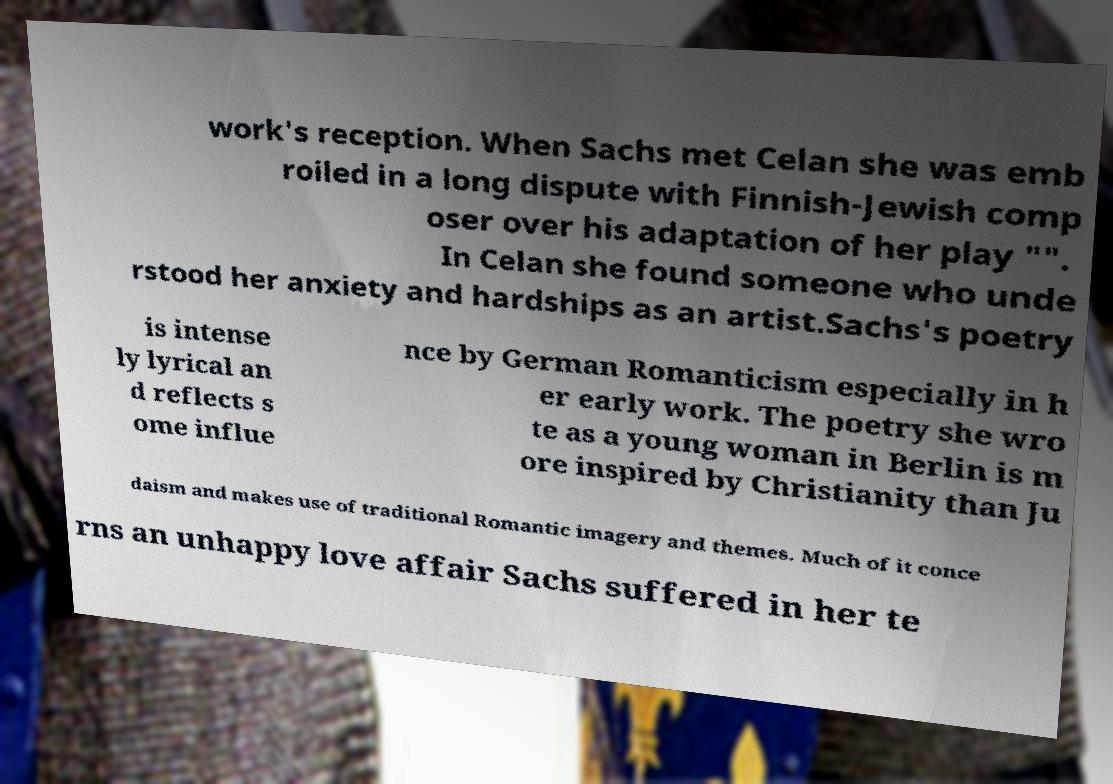Can you read and provide the text displayed in the image?This photo seems to have some interesting text. Can you extract and type it out for me? work's reception. When Sachs met Celan she was emb roiled in a long dispute with Finnish-Jewish comp oser over his adaptation of her play "". In Celan she found someone who unde rstood her anxiety and hardships as an artist.Sachs's poetry is intense ly lyrical an d reflects s ome influe nce by German Romanticism especially in h er early work. The poetry she wro te as a young woman in Berlin is m ore inspired by Christianity than Ju daism and makes use of traditional Romantic imagery and themes. Much of it conce rns an unhappy love affair Sachs suffered in her te 